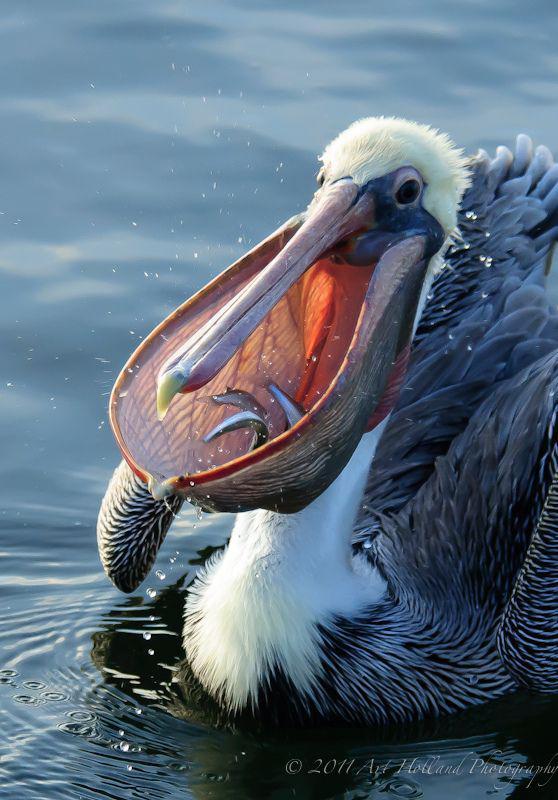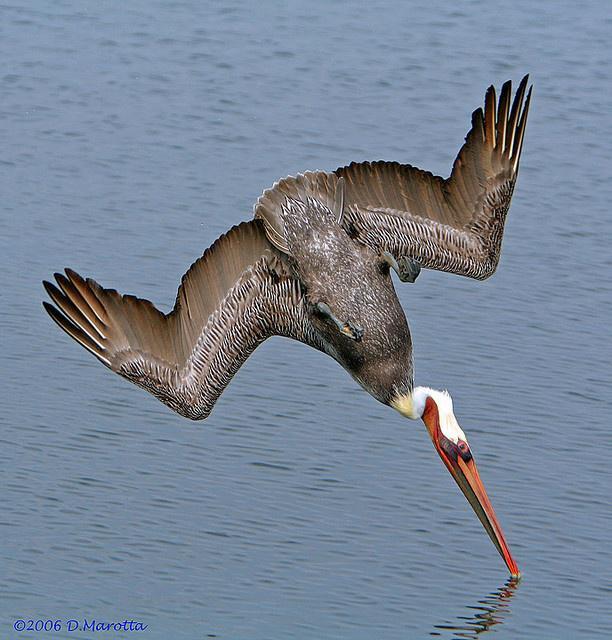The first image is the image on the left, the second image is the image on the right. Assess this claim about the two images: "One white-bodied pelican has a closed beak and is in the air above the water with spread wings.". Correct or not? Answer yes or no. No. The first image is the image on the left, the second image is the image on the right. Examine the images to the left and right. Is the description "The bird in the image on the right is in flight." accurate? Answer yes or no. Yes. The first image is the image on the left, the second image is the image on the right. Examine the images to the left and right. Is the description "A bird flies right above the water in the image on the right." accurate? Answer yes or no. Yes. The first image is the image on the left, the second image is the image on the right. Given the left and right images, does the statement "A fish is visible in the distended lower bill of a floating pelican with its body facing the camera." hold true? Answer yes or no. Yes. 